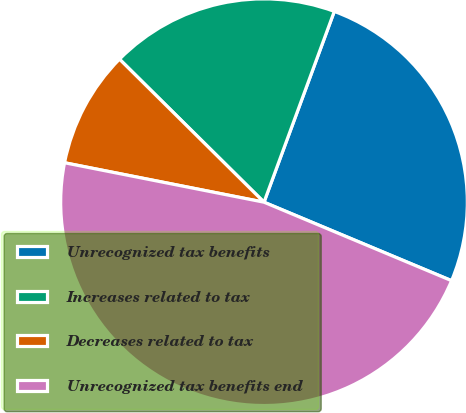Convert chart. <chart><loc_0><loc_0><loc_500><loc_500><pie_chart><fcel>Unrecognized tax benefits<fcel>Increases related to tax<fcel>Decreases related to tax<fcel>Unrecognized tax benefits end<nl><fcel>25.69%<fcel>18.2%<fcel>9.31%<fcel>46.8%<nl></chart> 